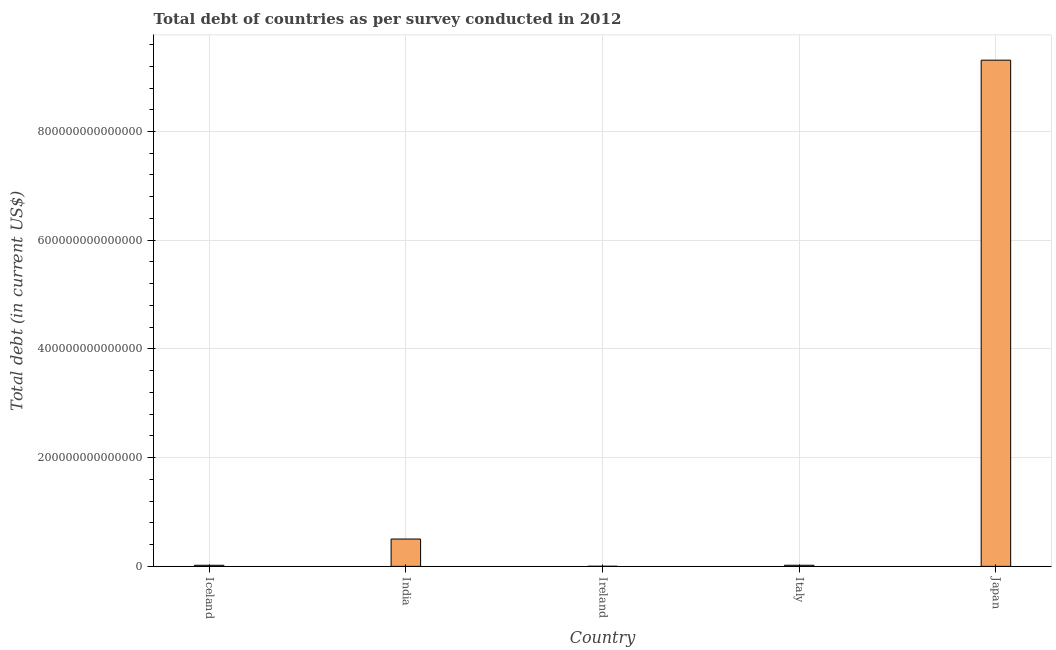What is the title of the graph?
Offer a very short reply. Total debt of countries as per survey conducted in 2012. What is the label or title of the Y-axis?
Offer a very short reply. Total debt (in current US$). What is the total debt in Italy?
Give a very brief answer. 2.05e+12. Across all countries, what is the maximum total debt?
Your answer should be compact. 9.31e+14. Across all countries, what is the minimum total debt?
Your response must be concise. 2.08e+11. In which country was the total debt minimum?
Ensure brevity in your answer.  Ireland. What is the sum of the total debt?
Provide a short and direct response. 9.86e+14. What is the difference between the total debt in Iceland and Japan?
Your answer should be compact. -9.29e+14. What is the average total debt per country?
Ensure brevity in your answer.  1.97e+14. What is the median total debt?
Make the answer very short. 2.05e+12. What is the ratio of the total debt in India to that in Japan?
Your answer should be compact. 0.05. Is the difference between the total debt in India and Ireland greater than the difference between any two countries?
Your answer should be very brief. No. What is the difference between the highest and the second highest total debt?
Your answer should be very brief. 8.81e+14. What is the difference between the highest and the lowest total debt?
Provide a succinct answer. 9.31e+14. How many bars are there?
Your answer should be very brief. 5. Are all the bars in the graph horizontal?
Ensure brevity in your answer.  No. What is the difference between two consecutive major ticks on the Y-axis?
Provide a succinct answer. 2.00e+14. What is the Total debt (in current US$) of Iceland?
Your answer should be compact. 2.00e+12. What is the Total debt (in current US$) in India?
Provide a short and direct response. 5.03e+13. What is the Total debt (in current US$) in Ireland?
Your answer should be compact. 2.08e+11. What is the Total debt (in current US$) of Italy?
Offer a very short reply. 2.05e+12. What is the Total debt (in current US$) of Japan?
Your response must be concise. 9.31e+14. What is the difference between the Total debt (in current US$) in Iceland and India?
Your response must be concise. -4.83e+13. What is the difference between the Total debt (in current US$) in Iceland and Ireland?
Offer a terse response. 1.79e+12. What is the difference between the Total debt (in current US$) in Iceland and Italy?
Keep it short and to the point. -5.63e+1. What is the difference between the Total debt (in current US$) in Iceland and Japan?
Provide a short and direct response. -9.29e+14. What is the difference between the Total debt (in current US$) in India and Ireland?
Offer a terse response. 5.00e+13. What is the difference between the Total debt (in current US$) in India and Italy?
Give a very brief answer. 4.82e+13. What is the difference between the Total debt (in current US$) in India and Japan?
Offer a very short reply. -8.81e+14. What is the difference between the Total debt (in current US$) in Ireland and Italy?
Your response must be concise. -1.85e+12. What is the difference between the Total debt (in current US$) in Ireland and Japan?
Your answer should be compact. -9.31e+14. What is the difference between the Total debt (in current US$) in Italy and Japan?
Your response must be concise. -9.29e+14. What is the ratio of the Total debt (in current US$) in Iceland to that in India?
Give a very brief answer. 0.04. What is the ratio of the Total debt (in current US$) in Iceland to that in Italy?
Provide a succinct answer. 0.97. What is the ratio of the Total debt (in current US$) in Iceland to that in Japan?
Ensure brevity in your answer.  0. What is the ratio of the Total debt (in current US$) in India to that in Ireland?
Offer a terse response. 241.49. What is the ratio of the Total debt (in current US$) in India to that in Italy?
Provide a succinct answer. 24.47. What is the ratio of the Total debt (in current US$) in India to that in Japan?
Make the answer very short. 0.05. What is the ratio of the Total debt (in current US$) in Ireland to that in Italy?
Your answer should be very brief. 0.1. What is the ratio of the Total debt (in current US$) in Italy to that in Japan?
Your answer should be very brief. 0. 